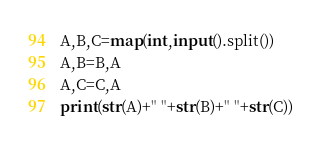Convert code to text. <code><loc_0><loc_0><loc_500><loc_500><_Python_>A,B,C=map(int,input().split())
A,B=B,A
A,C=C,A
print(str(A)+" "+str(B)+" "+str(C))</code> 